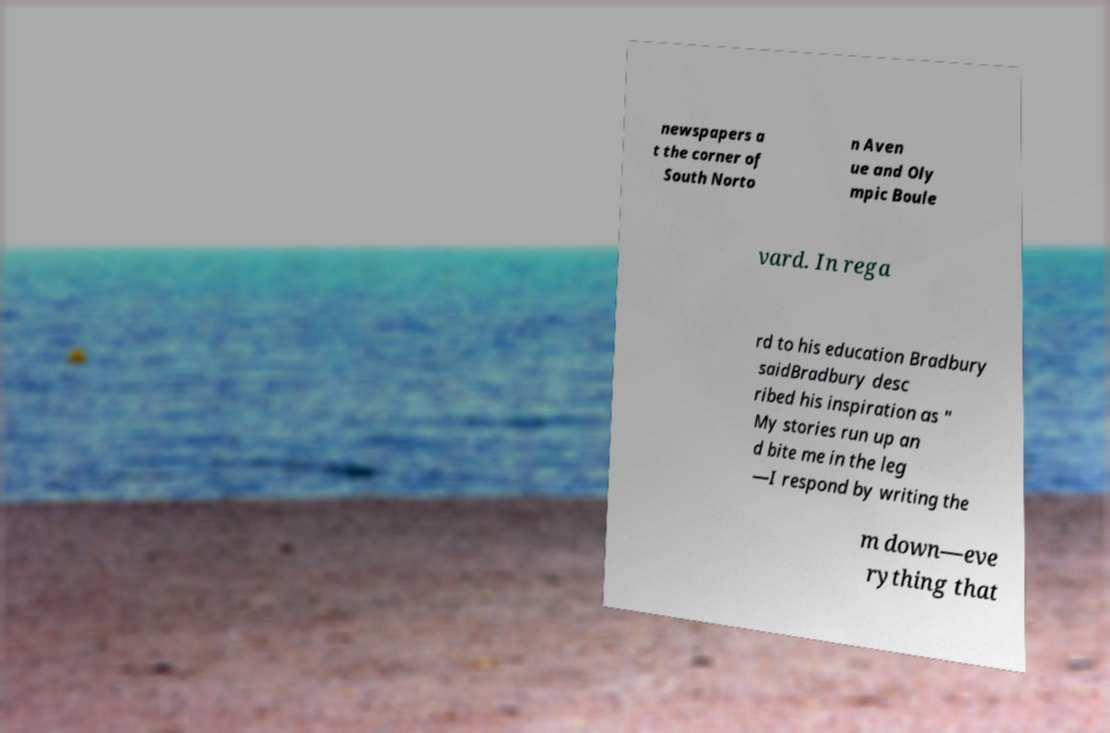There's text embedded in this image that I need extracted. Can you transcribe it verbatim? newspapers a t the corner of South Norto n Aven ue and Oly mpic Boule vard. In rega rd to his education Bradbury saidBradbury desc ribed his inspiration as " My stories run up an d bite me in the leg —I respond by writing the m down—eve rything that 